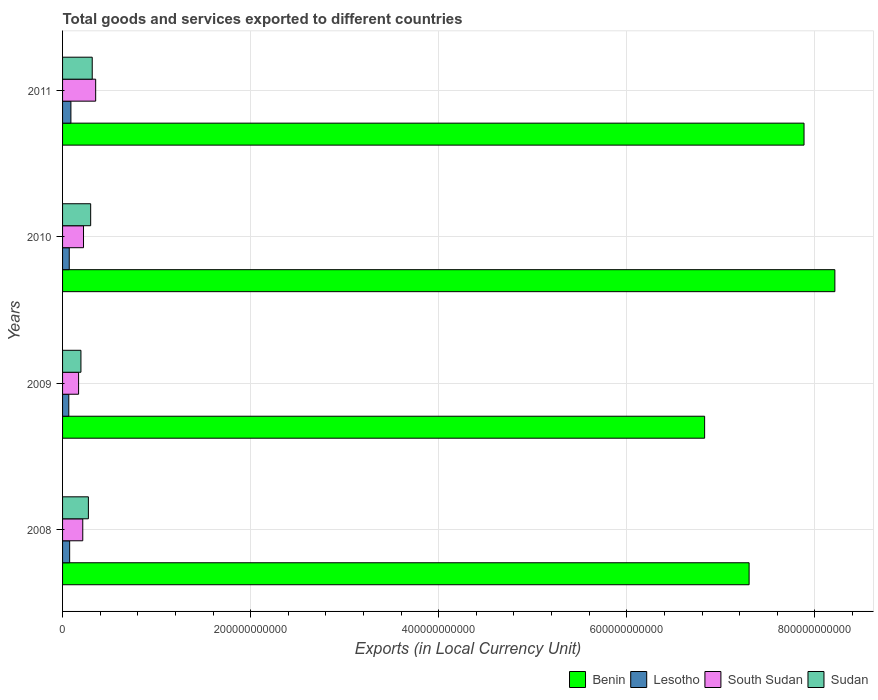How many groups of bars are there?
Your response must be concise. 4. Are the number of bars on each tick of the Y-axis equal?
Give a very brief answer. Yes. What is the label of the 1st group of bars from the top?
Offer a terse response. 2011. In how many cases, is the number of bars for a given year not equal to the number of legend labels?
Your answer should be very brief. 0. What is the Amount of goods and services exports in South Sudan in 2009?
Ensure brevity in your answer.  1.70e+1. Across all years, what is the maximum Amount of goods and services exports in South Sudan?
Your response must be concise. 3.52e+1. Across all years, what is the minimum Amount of goods and services exports in Benin?
Keep it short and to the point. 6.83e+11. What is the total Amount of goods and services exports in South Sudan in the graph?
Ensure brevity in your answer.  9.60e+1. What is the difference between the Amount of goods and services exports in Benin in 2008 and that in 2009?
Offer a very short reply. 4.73e+1. What is the difference between the Amount of goods and services exports in Lesotho in 2009 and the Amount of goods and services exports in Benin in 2008?
Your response must be concise. -7.23e+11. What is the average Amount of goods and services exports in Benin per year?
Make the answer very short. 7.56e+11. In the year 2009, what is the difference between the Amount of goods and services exports in Sudan and Amount of goods and services exports in Benin?
Offer a very short reply. -6.63e+11. In how many years, is the Amount of goods and services exports in Benin greater than 320000000000 LCU?
Your response must be concise. 4. What is the ratio of the Amount of goods and services exports in Sudan in 2008 to that in 2011?
Provide a succinct answer. 0.87. Is the difference between the Amount of goods and services exports in Sudan in 2009 and 2010 greater than the difference between the Amount of goods and services exports in Benin in 2009 and 2010?
Offer a terse response. Yes. What is the difference between the highest and the second highest Amount of goods and services exports in Lesotho?
Offer a terse response. 1.32e+09. What is the difference between the highest and the lowest Amount of goods and services exports in Sudan?
Offer a very short reply. 1.20e+1. In how many years, is the Amount of goods and services exports in Benin greater than the average Amount of goods and services exports in Benin taken over all years?
Offer a terse response. 2. Is the sum of the Amount of goods and services exports in Benin in 2009 and 2011 greater than the maximum Amount of goods and services exports in Lesotho across all years?
Offer a very short reply. Yes. Is it the case that in every year, the sum of the Amount of goods and services exports in Sudan and Amount of goods and services exports in Lesotho is greater than the sum of Amount of goods and services exports in Benin and Amount of goods and services exports in South Sudan?
Your answer should be compact. No. What does the 1st bar from the top in 2010 represents?
Make the answer very short. Sudan. What does the 2nd bar from the bottom in 2009 represents?
Provide a succinct answer. Lesotho. How many bars are there?
Keep it short and to the point. 16. Are all the bars in the graph horizontal?
Provide a succinct answer. Yes. How many years are there in the graph?
Provide a short and direct response. 4. What is the difference between two consecutive major ticks on the X-axis?
Your response must be concise. 2.00e+11. Are the values on the major ticks of X-axis written in scientific E-notation?
Your answer should be very brief. No. What is the title of the graph?
Your response must be concise. Total goods and services exported to different countries. Does "United Kingdom" appear as one of the legend labels in the graph?
Make the answer very short. No. What is the label or title of the X-axis?
Provide a succinct answer. Exports (in Local Currency Unit). What is the label or title of the Y-axis?
Provide a succinct answer. Years. What is the Exports (in Local Currency Unit) of Benin in 2008?
Make the answer very short. 7.30e+11. What is the Exports (in Local Currency Unit) of Lesotho in 2008?
Offer a terse response. 7.55e+09. What is the Exports (in Local Currency Unit) in South Sudan in 2008?
Provide a short and direct response. 2.15e+1. What is the Exports (in Local Currency Unit) in Sudan in 2008?
Offer a terse response. 2.75e+1. What is the Exports (in Local Currency Unit) in Benin in 2009?
Your answer should be compact. 6.83e+11. What is the Exports (in Local Currency Unit) in Lesotho in 2009?
Your answer should be compact. 6.63e+09. What is the Exports (in Local Currency Unit) in South Sudan in 2009?
Ensure brevity in your answer.  1.70e+1. What is the Exports (in Local Currency Unit) in Sudan in 2009?
Provide a succinct answer. 1.95e+1. What is the Exports (in Local Currency Unit) of Benin in 2010?
Offer a terse response. 8.21e+11. What is the Exports (in Local Currency Unit) in Lesotho in 2010?
Keep it short and to the point. 7.11e+09. What is the Exports (in Local Currency Unit) in South Sudan in 2010?
Your response must be concise. 2.23e+1. What is the Exports (in Local Currency Unit) in Sudan in 2010?
Your response must be concise. 2.99e+1. What is the Exports (in Local Currency Unit) in Benin in 2011?
Offer a very short reply. 7.88e+11. What is the Exports (in Local Currency Unit) in Lesotho in 2011?
Provide a succinct answer. 8.86e+09. What is the Exports (in Local Currency Unit) in South Sudan in 2011?
Ensure brevity in your answer.  3.52e+1. What is the Exports (in Local Currency Unit) of Sudan in 2011?
Keep it short and to the point. 3.15e+1. Across all years, what is the maximum Exports (in Local Currency Unit) of Benin?
Offer a very short reply. 8.21e+11. Across all years, what is the maximum Exports (in Local Currency Unit) of Lesotho?
Offer a terse response. 8.86e+09. Across all years, what is the maximum Exports (in Local Currency Unit) in South Sudan?
Keep it short and to the point. 3.52e+1. Across all years, what is the maximum Exports (in Local Currency Unit) of Sudan?
Make the answer very short. 3.15e+1. Across all years, what is the minimum Exports (in Local Currency Unit) of Benin?
Provide a short and direct response. 6.83e+11. Across all years, what is the minimum Exports (in Local Currency Unit) of Lesotho?
Make the answer very short. 6.63e+09. Across all years, what is the minimum Exports (in Local Currency Unit) in South Sudan?
Your answer should be very brief. 1.70e+1. Across all years, what is the minimum Exports (in Local Currency Unit) of Sudan?
Ensure brevity in your answer.  1.95e+1. What is the total Exports (in Local Currency Unit) of Benin in the graph?
Give a very brief answer. 3.02e+12. What is the total Exports (in Local Currency Unit) in Lesotho in the graph?
Your answer should be very brief. 3.01e+1. What is the total Exports (in Local Currency Unit) in South Sudan in the graph?
Make the answer very short. 9.60e+1. What is the total Exports (in Local Currency Unit) in Sudan in the graph?
Offer a terse response. 1.08e+11. What is the difference between the Exports (in Local Currency Unit) of Benin in 2008 and that in 2009?
Make the answer very short. 4.73e+1. What is the difference between the Exports (in Local Currency Unit) in Lesotho in 2008 and that in 2009?
Your response must be concise. 9.15e+08. What is the difference between the Exports (in Local Currency Unit) of South Sudan in 2008 and that in 2009?
Ensure brevity in your answer.  4.43e+09. What is the difference between the Exports (in Local Currency Unit) in Sudan in 2008 and that in 2009?
Your answer should be compact. 7.93e+09. What is the difference between the Exports (in Local Currency Unit) of Benin in 2008 and that in 2010?
Give a very brief answer. -9.12e+1. What is the difference between the Exports (in Local Currency Unit) of Lesotho in 2008 and that in 2010?
Your answer should be compact. 4.40e+08. What is the difference between the Exports (in Local Currency Unit) in South Sudan in 2008 and that in 2010?
Provide a succinct answer. -7.98e+08. What is the difference between the Exports (in Local Currency Unit) in Sudan in 2008 and that in 2010?
Keep it short and to the point. -2.42e+09. What is the difference between the Exports (in Local Currency Unit) in Benin in 2008 and that in 2011?
Your answer should be very brief. -5.84e+1. What is the difference between the Exports (in Local Currency Unit) in Lesotho in 2008 and that in 2011?
Your response must be concise. -1.32e+09. What is the difference between the Exports (in Local Currency Unit) in South Sudan in 2008 and that in 2011?
Your answer should be very brief. -1.37e+1. What is the difference between the Exports (in Local Currency Unit) of Sudan in 2008 and that in 2011?
Your answer should be very brief. -4.08e+09. What is the difference between the Exports (in Local Currency Unit) of Benin in 2009 and that in 2010?
Provide a succinct answer. -1.38e+11. What is the difference between the Exports (in Local Currency Unit) in Lesotho in 2009 and that in 2010?
Your response must be concise. -4.74e+08. What is the difference between the Exports (in Local Currency Unit) in South Sudan in 2009 and that in 2010?
Your answer should be compact. -5.23e+09. What is the difference between the Exports (in Local Currency Unit) of Sudan in 2009 and that in 2010?
Your answer should be compact. -1.03e+1. What is the difference between the Exports (in Local Currency Unit) in Benin in 2009 and that in 2011?
Offer a terse response. -1.06e+11. What is the difference between the Exports (in Local Currency Unit) of Lesotho in 2009 and that in 2011?
Your answer should be compact. -2.23e+09. What is the difference between the Exports (in Local Currency Unit) of South Sudan in 2009 and that in 2011?
Keep it short and to the point. -1.82e+1. What is the difference between the Exports (in Local Currency Unit) in Sudan in 2009 and that in 2011?
Keep it short and to the point. -1.20e+1. What is the difference between the Exports (in Local Currency Unit) of Benin in 2010 and that in 2011?
Keep it short and to the point. 3.28e+1. What is the difference between the Exports (in Local Currency Unit) in Lesotho in 2010 and that in 2011?
Make the answer very short. -1.76e+09. What is the difference between the Exports (in Local Currency Unit) in South Sudan in 2010 and that in 2011?
Ensure brevity in your answer.  -1.29e+1. What is the difference between the Exports (in Local Currency Unit) in Sudan in 2010 and that in 2011?
Keep it short and to the point. -1.66e+09. What is the difference between the Exports (in Local Currency Unit) in Benin in 2008 and the Exports (in Local Currency Unit) in Lesotho in 2009?
Make the answer very short. 7.23e+11. What is the difference between the Exports (in Local Currency Unit) of Benin in 2008 and the Exports (in Local Currency Unit) of South Sudan in 2009?
Ensure brevity in your answer.  7.13e+11. What is the difference between the Exports (in Local Currency Unit) of Benin in 2008 and the Exports (in Local Currency Unit) of Sudan in 2009?
Offer a terse response. 7.10e+11. What is the difference between the Exports (in Local Currency Unit) of Lesotho in 2008 and the Exports (in Local Currency Unit) of South Sudan in 2009?
Provide a succinct answer. -9.49e+09. What is the difference between the Exports (in Local Currency Unit) in Lesotho in 2008 and the Exports (in Local Currency Unit) in Sudan in 2009?
Your answer should be very brief. -1.20e+1. What is the difference between the Exports (in Local Currency Unit) in South Sudan in 2008 and the Exports (in Local Currency Unit) in Sudan in 2009?
Make the answer very short. 1.94e+09. What is the difference between the Exports (in Local Currency Unit) in Benin in 2008 and the Exports (in Local Currency Unit) in Lesotho in 2010?
Give a very brief answer. 7.23e+11. What is the difference between the Exports (in Local Currency Unit) of Benin in 2008 and the Exports (in Local Currency Unit) of South Sudan in 2010?
Offer a terse response. 7.08e+11. What is the difference between the Exports (in Local Currency Unit) of Benin in 2008 and the Exports (in Local Currency Unit) of Sudan in 2010?
Your answer should be compact. 7.00e+11. What is the difference between the Exports (in Local Currency Unit) of Lesotho in 2008 and the Exports (in Local Currency Unit) of South Sudan in 2010?
Your answer should be very brief. -1.47e+1. What is the difference between the Exports (in Local Currency Unit) of Lesotho in 2008 and the Exports (in Local Currency Unit) of Sudan in 2010?
Keep it short and to the point. -2.23e+1. What is the difference between the Exports (in Local Currency Unit) of South Sudan in 2008 and the Exports (in Local Currency Unit) of Sudan in 2010?
Your answer should be very brief. -8.41e+09. What is the difference between the Exports (in Local Currency Unit) in Benin in 2008 and the Exports (in Local Currency Unit) in Lesotho in 2011?
Your answer should be very brief. 7.21e+11. What is the difference between the Exports (in Local Currency Unit) in Benin in 2008 and the Exports (in Local Currency Unit) in South Sudan in 2011?
Offer a very short reply. 6.95e+11. What is the difference between the Exports (in Local Currency Unit) of Benin in 2008 and the Exports (in Local Currency Unit) of Sudan in 2011?
Your answer should be very brief. 6.98e+11. What is the difference between the Exports (in Local Currency Unit) of Lesotho in 2008 and the Exports (in Local Currency Unit) of South Sudan in 2011?
Offer a terse response. -2.77e+1. What is the difference between the Exports (in Local Currency Unit) of Lesotho in 2008 and the Exports (in Local Currency Unit) of Sudan in 2011?
Ensure brevity in your answer.  -2.40e+1. What is the difference between the Exports (in Local Currency Unit) in South Sudan in 2008 and the Exports (in Local Currency Unit) in Sudan in 2011?
Make the answer very short. -1.01e+1. What is the difference between the Exports (in Local Currency Unit) in Benin in 2009 and the Exports (in Local Currency Unit) in Lesotho in 2010?
Make the answer very short. 6.76e+11. What is the difference between the Exports (in Local Currency Unit) of Benin in 2009 and the Exports (in Local Currency Unit) of South Sudan in 2010?
Make the answer very short. 6.60e+11. What is the difference between the Exports (in Local Currency Unit) of Benin in 2009 and the Exports (in Local Currency Unit) of Sudan in 2010?
Ensure brevity in your answer.  6.53e+11. What is the difference between the Exports (in Local Currency Unit) in Lesotho in 2009 and the Exports (in Local Currency Unit) in South Sudan in 2010?
Ensure brevity in your answer.  -1.56e+1. What is the difference between the Exports (in Local Currency Unit) in Lesotho in 2009 and the Exports (in Local Currency Unit) in Sudan in 2010?
Keep it short and to the point. -2.33e+1. What is the difference between the Exports (in Local Currency Unit) of South Sudan in 2009 and the Exports (in Local Currency Unit) of Sudan in 2010?
Make the answer very short. -1.28e+1. What is the difference between the Exports (in Local Currency Unit) in Benin in 2009 and the Exports (in Local Currency Unit) in Lesotho in 2011?
Provide a succinct answer. 6.74e+11. What is the difference between the Exports (in Local Currency Unit) in Benin in 2009 and the Exports (in Local Currency Unit) in South Sudan in 2011?
Give a very brief answer. 6.47e+11. What is the difference between the Exports (in Local Currency Unit) in Benin in 2009 and the Exports (in Local Currency Unit) in Sudan in 2011?
Keep it short and to the point. 6.51e+11. What is the difference between the Exports (in Local Currency Unit) in Lesotho in 2009 and the Exports (in Local Currency Unit) in South Sudan in 2011?
Give a very brief answer. -2.86e+1. What is the difference between the Exports (in Local Currency Unit) in Lesotho in 2009 and the Exports (in Local Currency Unit) in Sudan in 2011?
Your response must be concise. -2.49e+1. What is the difference between the Exports (in Local Currency Unit) of South Sudan in 2009 and the Exports (in Local Currency Unit) of Sudan in 2011?
Your answer should be compact. -1.45e+1. What is the difference between the Exports (in Local Currency Unit) in Benin in 2010 and the Exports (in Local Currency Unit) in Lesotho in 2011?
Your answer should be very brief. 8.12e+11. What is the difference between the Exports (in Local Currency Unit) of Benin in 2010 and the Exports (in Local Currency Unit) of South Sudan in 2011?
Keep it short and to the point. 7.86e+11. What is the difference between the Exports (in Local Currency Unit) in Benin in 2010 and the Exports (in Local Currency Unit) in Sudan in 2011?
Ensure brevity in your answer.  7.90e+11. What is the difference between the Exports (in Local Currency Unit) in Lesotho in 2010 and the Exports (in Local Currency Unit) in South Sudan in 2011?
Offer a terse response. -2.81e+1. What is the difference between the Exports (in Local Currency Unit) of Lesotho in 2010 and the Exports (in Local Currency Unit) of Sudan in 2011?
Ensure brevity in your answer.  -2.44e+1. What is the difference between the Exports (in Local Currency Unit) in South Sudan in 2010 and the Exports (in Local Currency Unit) in Sudan in 2011?
Offer a terse response. -9.27e+09. What is the average Exports (in Local Currency Unit) in Benin per year?
Offer a very short reply. 7.56e+11. What is the average Exports (in Local Currency Unit) of Lesotho per year?
Give a very brief answer. 7.54e+09. What is the average Exports (in Local Currency Unit) of South Sudan per year?
Offer a very short reply. 2.40e+1. What is the average Exports (in Local Currency Unit) in Sudan per year?
Your answer should be very brief. 2.71e+1. In the year 2008, what is the difference between the Exports (in Local Currency Unit) of Benin and Exports (in Local Currency Unit) of Lesotho?
Keep it short and to the point. 7.22e+11. In the year 2008, what is the difference between the Exports (in Local Currency Unit) of Benin and Exports (in Local Currency Unit) of South Sudan?
Offer a very short reply. 7.09e+11. In the year 2008, what is the difference between the Exports (in Local Currency Unit) in Benin and Exports (in Local Currency Unit) in Sudan?
Your answer should be very brief. 7.03e+11. In the year 2008, what is the difference between the Exports (in Local Currency Unit) of Lesotho and Exports (in Local Currency Unit) of South Sudan?
Your answer should be compact. -1.39e+1. In the year 2008, what is the difference between the Exports (in Local Currency Unit) in Lesotho and Exports (in Local Currency Unit) in Sudan?
Keep it short and to the point. -1.99e+1. In the year 2008, what is the difference between the Exports (in Local Currency Unit) of South Sudan and Exports (in Local Currency Unit) of Sudan?
Ensure brevity in your answer.  -5.99e+09. In the year 2009, what is the difference between the Exports (in Local Currency Unit) in Benin and Exports (in Local Currency Unit) in Lesotho?
Keep it short and to the point. 6.76e+11. In the year 2009, what is the difference between the Exports (in Local Currency Unit) in Benin and Exports (in Local Currency Unit) in South Sudan?
Your response must be concise. 6.66e+11. In the year 2009, what is the difference between the Exports (in Local Currency Unit) of Benin and Exports (in Local Currency Unit) of Sudan?
Your response must be concise. 6.63e+11. In the year 2009, what is the difference between the Exports (in Local Currency Unit) of Lesotho and Exports (in Local Currency Unit) of South Sudan?
Provide a short and direct response. -1.04e+1. In the year 2009, what is the difference between the Exports (in Local Currency Unit) of Lesotho and Exports (in Local Currency Unit) of Sudan?
Your answer should be compact. -1.29e+1. In the year 2009, what is the difference between the Exports (in Local Currency Unit) in South Sudan and Exports (in Local Currency Unit) in Sudan?
Ensure brevity in your answer.  -2.49e+09. In the year 2010, what is the difference between the Exports (in Local Currency Unit) in Benin and Exports (in Local Currency Unit) in Lesotho?
Make the answer very short. 8.14e+11. In the year 2010, what is the difference between the Exports (in Local Currency Unit) in Benin and Exports (in Local Currency Unit) in South Sudan?
Offer a very short reply. 7.99e+11. In the year 2010, what is the difference between the Exports (in Local Currency Unit) in Benin and Exports (in Local Currency Unit) in Sudan?
Keep it short and to the point. 7.91e+11. In the year 2010, what is the difference between the Exports (in Local Currency Unit) of Lesotho and Exports (in Local Currency Unit) of South Sudan?
Offer a very short reply. -1.52e+1. In the year 2010, what is the difference between the Exports (in Local Currency Unit) of Lesotho and Exports (in Local Currency Unit) of Sudan?
Offer a very short reply. -2.28e+1. In the year 2010, what is the difference between the Exports (in Local Currency Unit) of South Sudan and Exports (in Local Currency Unit) of Sudan?
Offer a terse response. -7.61e+09. In the year 2011, what is the difference between the Exports (in Local Currency Unit) of Benin and Exports (in Local Currency Unit) of Lesotho?
Your response must be concise. 7.80e+11. In the year 2011, what is the difference between the Exports (in Local Currency Unit) in Benin and Exports (in Local Currency Unit) in South Sudan?
Your answer should be compact. 7.53e+11. In the year 2011, what is the difference between the Exports (in Local Currency Unit) of Benin and Exports (in Local Currency Unit) of Sudan?
Keep it short and to the point. 7.57e+11. In the year 2011, what is the difference between the Exports (in Local Currency Unit) in Lesotho and Exports (in Local Currency Unit) in South Sudan?
Ensure brevity in your answer.  -2.63e+1. In the year 2011, what is the difference between the Exports (in Local Currency Unit) in Lesotho and Exports (in Local Currency Unit) in Sudan?
Provide a succinct answer. -2.27e+1. In the year 2011, what is the difference between the Exports (in Local Currency Unit) of South Sudan and Exports (in Local Currency Unit) of Sudan?
Offer a terse response. 3.67e+09. What is the ratio of the Exports (in Local Currency Unit) of Benin in 2008 to that in 2009?
Make the answer very short. 1.07. What is the ratio of the Exports (in Local Currency Unit) of Lesotho in 2008 to that in 2009?
Keep it short and to the point. 1.14. What is the ratio of the Exports (in Local Currency Unit) in South Sudan in 2008 to that in 2009?
Ensure brevity in your answer.  1.26. What is the ratio of the Exports (in Local Currency Unit) in Sudan in 2008 to that in 2009?
Provide a succinct answer. 1.41. What is the ratio of the Exports (in Local Currency Unit) of Lesotho in 2008 to that in 2010?
Provide a succinct answer. 1.06. What is the ratio of the Exports (in Local Currency Unit) in South Sudan in 2008 to that in 2010?
Your answer should be very brief. 0.96. What is the ratio of the Exports (in Local Currency Unit) of Sudan in 2008 to that in 2010?
Provide a succinct answer. 0.92. What is the ratio of the Exports (in Local Currency Unit) in Benin in 2008 to that in 2011?
Make the answer very short. 0.93. What is the ratio of the Exports (in Local Currency Unit) of Lesotho in 2008 to that in 2011?
Offer a terse response. 0.85. What is the ratio of the Exports (in Local Currency Unit) of South Sudan in 2008 to that in 2011?
Provide a succinct answer. 0.61. What is the ratio of the Exports (in Local Currency Unit) of Sudan in 2008 to that in 2011?
Provide a succinct answer. 0.87. What is the ratio of the Exports (in Local Currency Unit) of Benin in 2009 to that in 2010?
Make the answer very short. 0.83. What is the ratio of the Exports (in Local Currency Unit) of Lesotho in 2009 to that in 2010?
Provide a succinct answer. 0.93. What is the ratio of the Exports (in Local Currency Unit) of South Sudan in 2009 to that in 2010?
Offer a terse response. 0.77. What is the ratio of the Exports (in Local Currency Unit) in Sudan in 2009 to that in 2010?
Your answer should be compact. 0.65. What is the ratio of the Exports (in Local Currency Unit) of Benin in 2009 to that in 2011?
Make the answer very short. 0.87. What is the ratio of the Exports (in Local Currency Unit) in Lesotho in 2009 to that in 2011?
Your response must be concise. 0.75. What is the ratio of the Exports (in Local Currency Unit) in South Sudan in 2009 to that in 2011?
Give a very brief answer. 0.48. What is the ratio of the Exports (in Local Currency Unit) in Sudan in 2009 to that in 2011?
Provide a succinct answer. 0.62. What is the ratio of the Exports (in Local Currency Unit) of Benin in 2010 to that in 2011?
Your answer should be compact. 1.04. What is the ratio of the Exports (in Local Currency Unit) of Lesotho in 2010 to that in 2011?
Offer a very short reply. 0.8. What is the ratio of the Exports (in Local Currency Unit) of South Sudan in 2010 to that in 2011?
Give a very brief answer. 0.63. What is the ratio of the Exports (in Local Currency Unit) of Sudan in 2010 to that in 2011?
Provide a short and direct response. 0.95. What is the difference between the highest and the second highest Exports (in Local Currency Unit) in Benin?
Keep it short and to the point. 3.28e+1. What is the difference between the highest and the second highest Exports (in Local Currency Unit) of Lesotho?
Give a very brief answer. 1.32e+09. What is the difference between the highest and the second highest Exports (in Local Currency Unit) in South Sudan?
Keep it short and to the point. 1.29e+1. What is the difference between the highest and the second highest Exports (in Local Currency Unit) of Sudan?
Give a very brief answer. 1.66e+09. What is the difference between the highest and the lowest Exports (in Local Currency Unit) of Benin?
Make the answer very short. 1.38e+11. What is the difference between the highest and the lowest Exports (in Local Currency Unit) of Lesotho?
Give a very brief answer. 2.23e+09. What is the difference between the highest and the lowest Exports (in Local Currency Unit) in South Sudan?
Ensure brevity in your answer.  1.82e+1. What is the difference between the highest and the lowest Exports (in Local Currency Unit) of Sudan?
Your response must be concise. 1.20e+1. 